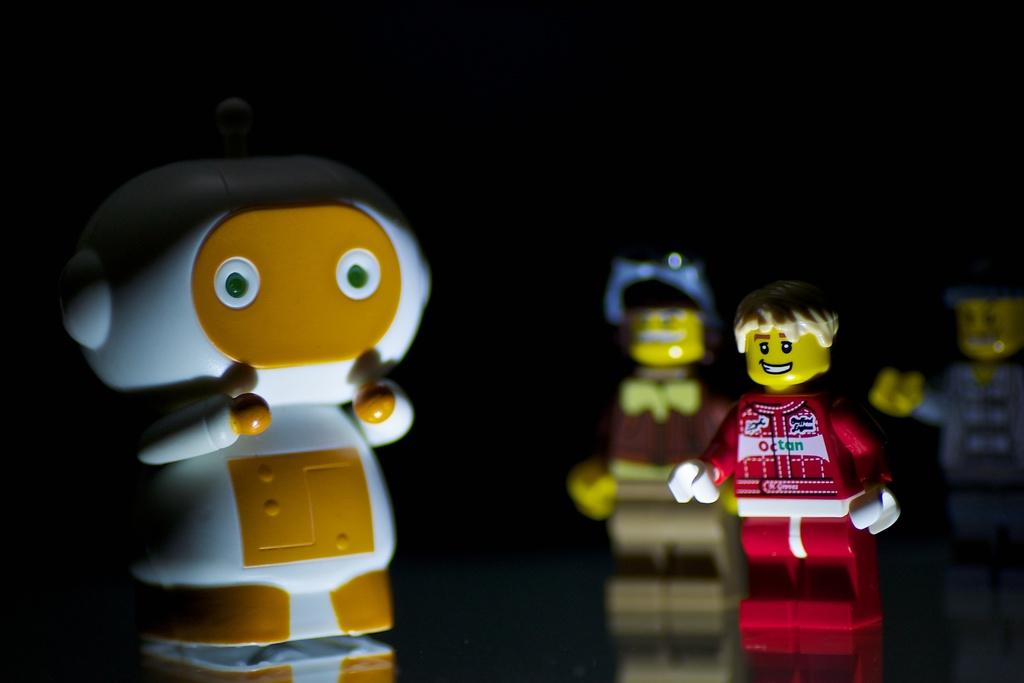What can be found in the image? There are different types of toys in the image. Where are the toys located? The toys are on a floor. What can be observed about the toys on the floor? There are reflections of toys on the floor. What is the color of the background in the image? The background of the image is black. What religious symbol is present in the image? There is no religious symbol present in the image; it features different types of toys on a floor with a black background. 